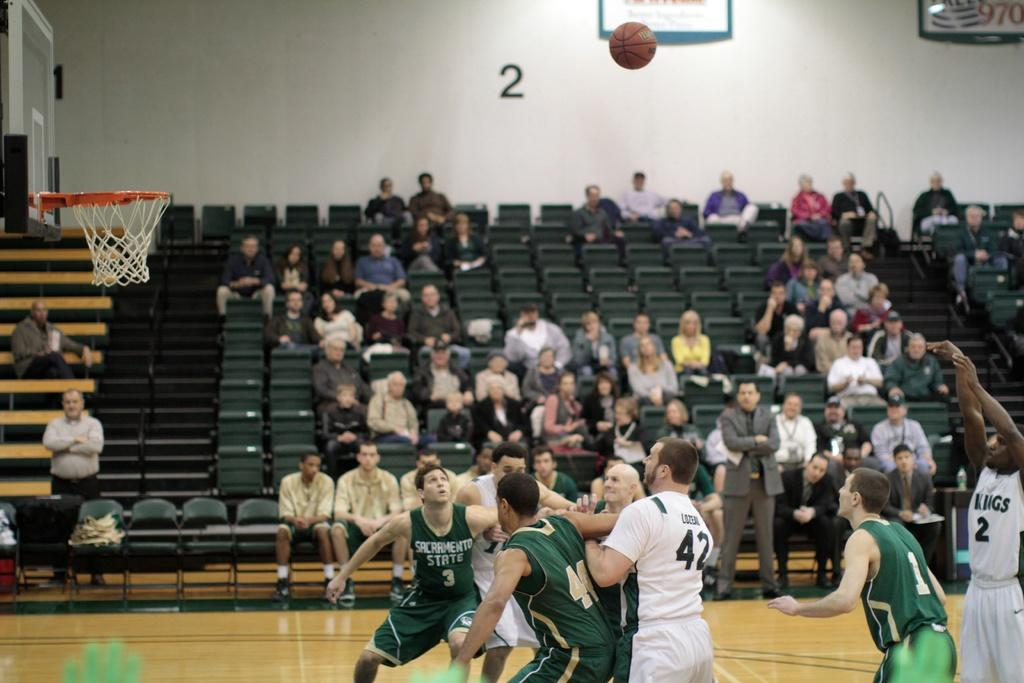<image>
Offer a succinct explanation of the picture presented. Man in a white number 2 jersey shooting a shot. 